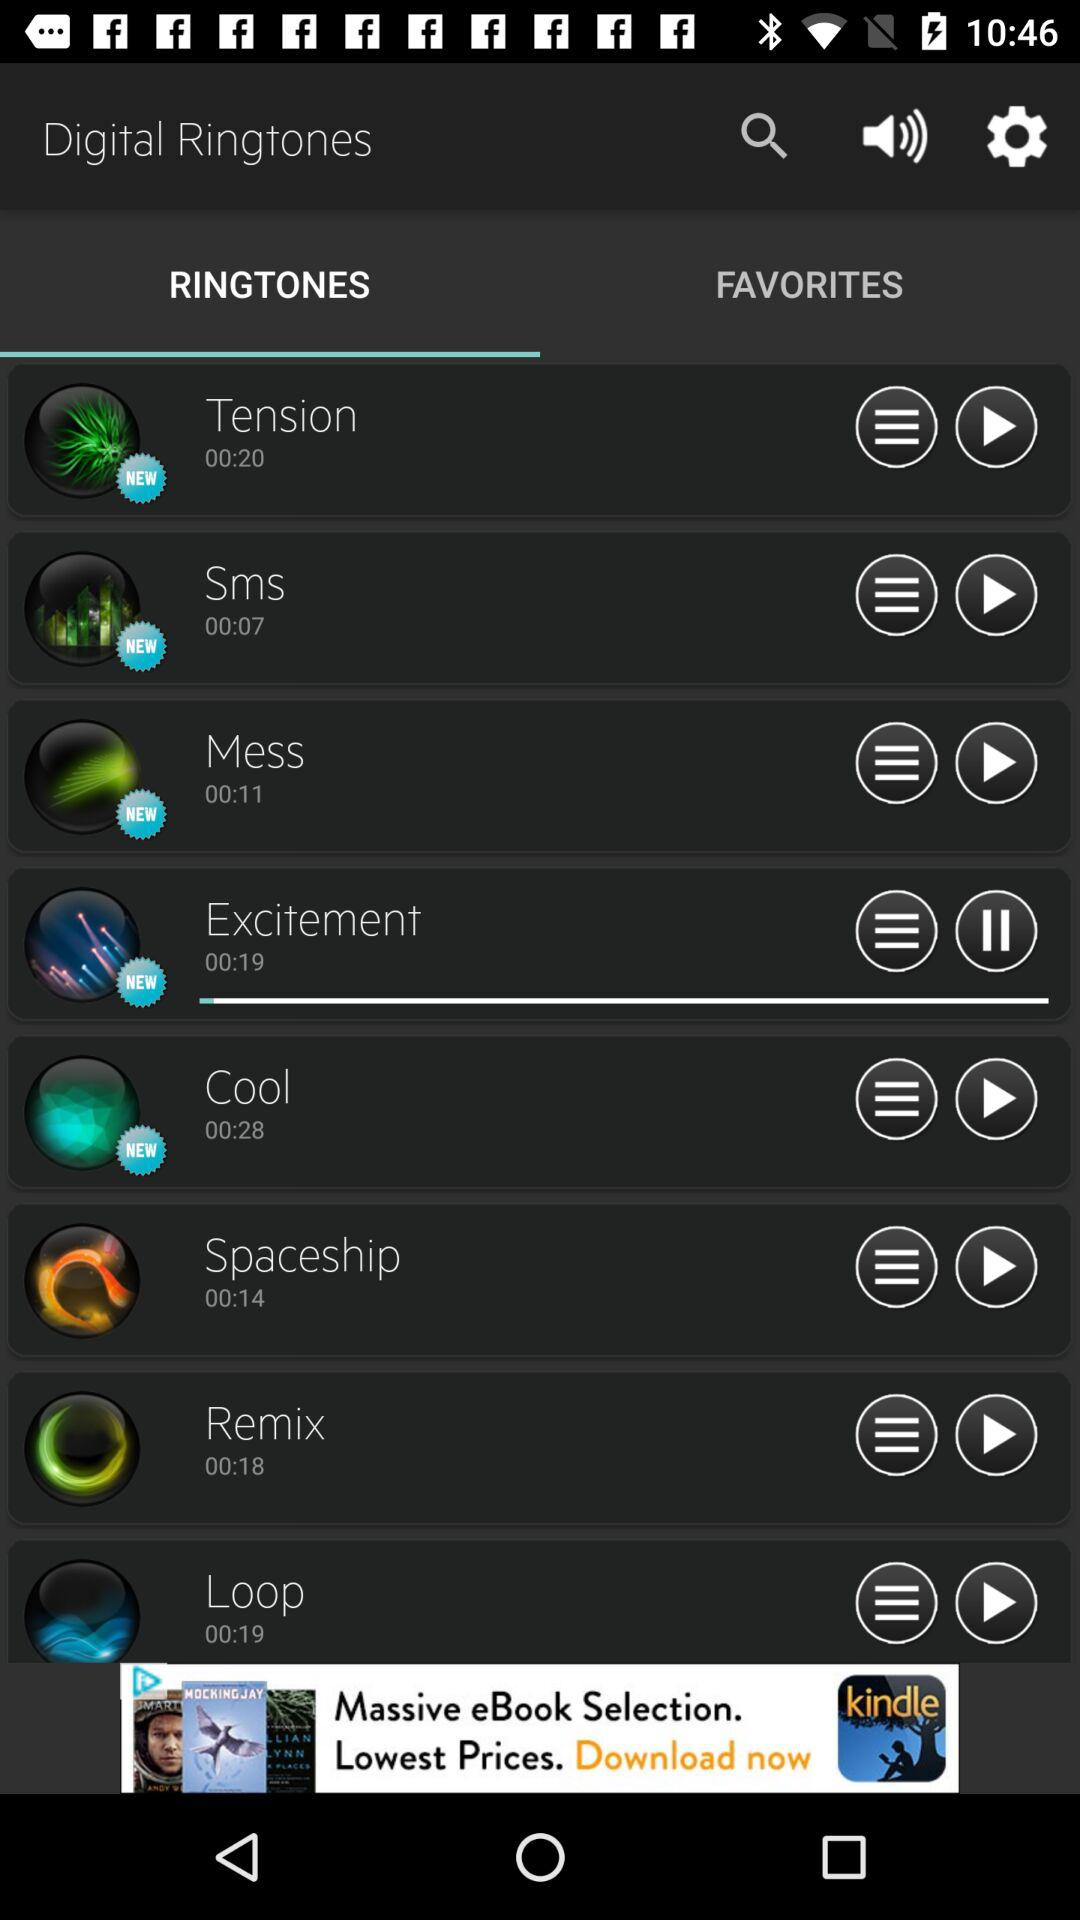What is the duration of the "Sms" audio? The duration of the "Sms" audio is 7 seconds. 